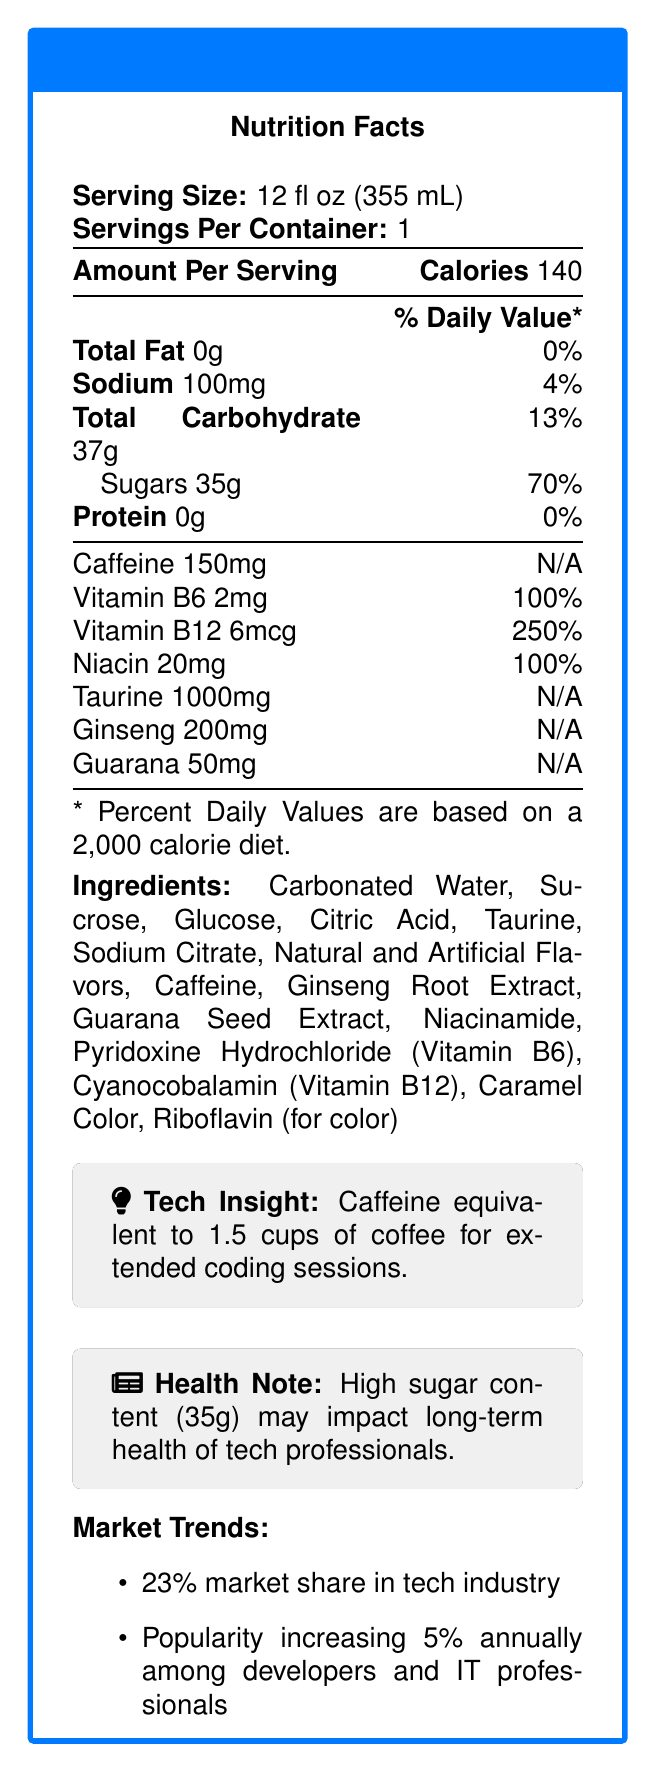what is the serving size of TechBoost Energy Drink? The serving size is clearly mentioned at the top of the nutrition facts label as "Serving Size: 12 fl oz (355 mL)".
Answer: 12 fl oz (355 mL) how many calories are in each serving? The amount of calories per serving is indicated at the top right of the nutrition facts label as "Calories 140".
Answer: 140 what percentage of the daily value for Vitamin B12 does one serving provide? Under the nutritional information, Vitamin B12 is listed as providing "250%" of the daily value per serving.
Answer: 250% how much sodium is there per serving? The sodium content per serving is listed in the nutritional breakdown as "Sodium 100mg".
Answer: 100mg name two ingredients found in TechBoost Energy Drink. The full list of ingredients is provided towards the bottom of the document, and among them are "Carbonated Water" and "Sucrose".
Answer: Carbonated Water, Sucrose how does the caffeine content of TechBoost Energy Drink compare to that of average energy drinks? According to the document's comparison to competitors section, TechBoost has "15% higher caffeine than average".
Answer: 15% higher than average which of the following vitamins is present in the highest daily value percentage per serving of TechBoost Energy Drink?
A. Vitamin B6
B. Vitamin B12
C. Niacin The nutritional information shows Vitamin B6 at 100%, Niacin at 100%, and Vitamin B12 at 250%, making Vitamin B12 the highest.
Answer: B which ingredient is most likely responsible for the potential health concern mentioned in the document?
A. Caffeine
B. Sugar
C. Taurine The health note highlights "high sugar content (35g)," making sugar the most likely cause for concern.
Answer: B does TechBoost Energy Drink contain any fats? The nutritional information clearly indicates "Total Fat 0g," implying there are no fats in TechBoost Energy Drink.
Answer: No can you determine the exact market share in percentage for TechBoost Energy Drink in the general energy drink market? The document only specifies the market share in the tech industry (23%), not in the general market.
Answer: Not enough information summarize the main idea of the document. The document outlines the nutritional aspects, ingredients, and market trends of TechBoost Energy Drink, while also giving insights into its effects on tech professionals and their health.
Answer: The document provides a nutritional breakdown of TechBoost Energy Drink, highlighting its high caffeine and sugar content, and presenting it as a popular option among tech professionals with a growing market share in the tech industry. Engineering insights and health concerns are also discussed. 